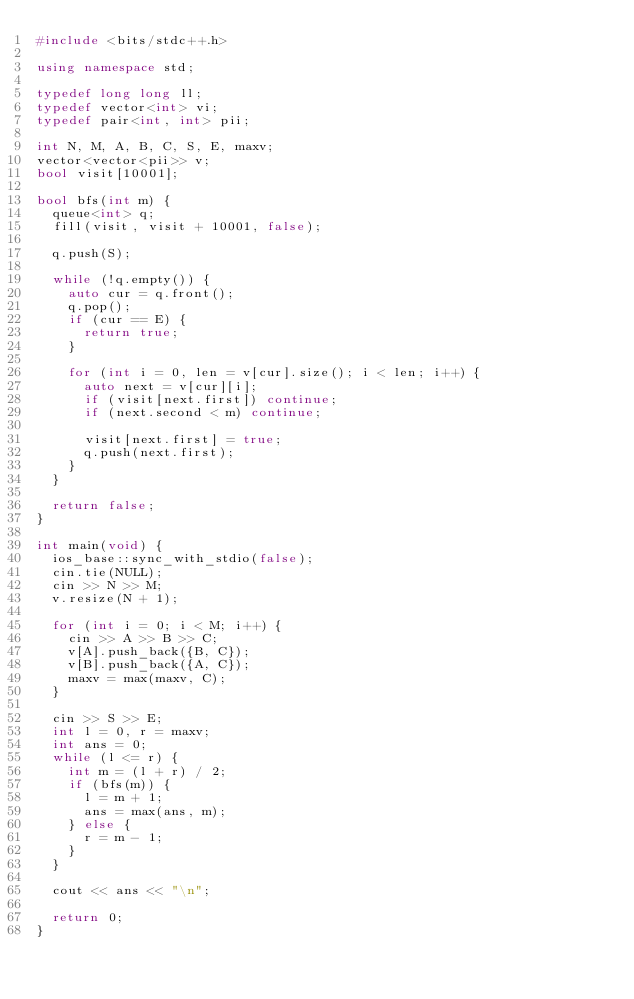<code> <loc_0><loc_0><loc_500><loc_500><_C++_>#include <bits/stdc++.h>

using namespace std;

typedef long long ll;
typedef vector<int> vi;
typedef pair<int, int> pii;

int N, M, A, B, C, S, E, maxv;
vector<vector<pii>> v;
bool visit[10001];

bool bfs(int m) {
  queue<int> q;
  fill(visit, visit + 10001, false);

  q.push(S);

  while (!q.empty()) {
    auto cur = q.front();
    q.pop();
    if (cur == E) {
      return true;
    }

    for (int i = 0, len = v[cur].size(); i < len; i++) {
      auto next = v[cur][i];
      if (visit[next.first]) continue;
      if (next.second < m) continue;

      visit[next.first] = true;
      q.push(next.first);
    }
  }

  return false;
}

int main(void) {
  ios_base::sync_with_stdio(false);
  cin.tie(NULL);
  cin >> N >> M;
  v.resize(N + 1);

  for (int i = 0; i < M; i++) {
    cin >> A >> B >> C;
    v[A].push_back({B, C});
    v[B].push_back({A, C});
    maxv = max(maxv, C);
  }

  cin >> S >> E;
  int l = 0, r = maxv;
  int ans = 0;
  while (l <= r) {
    int m = (l + r) / 2;
    if (bfs(m)) {
      l = m + 1;
      ans = max(ans, m);
    } else {
      r = m - 1;
    }
  }

  cout << ans << "\n";

  return 0;
}</code> 